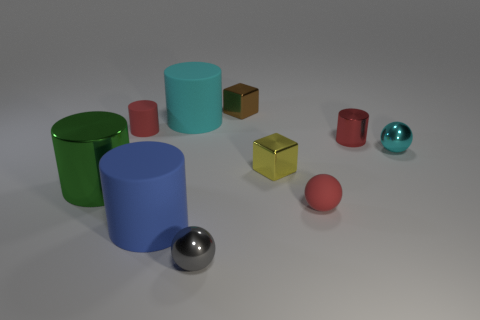What material is the red object that is behind the tiny yellow cube and to the right of the tiny gray shiny sphere?
Ensure brevity in your answer.  Metal. What number of tiny red rubber objects have the same shape as the small brown thing?
Give a very brief answer. 0. There is a sphere that is on the right side of the small red cylinder right of the blue matte cylinder; what is its size?
Give a very brief answer. Small. There is a small object that is right of the tiny red metallic cylinder; is it the same color as the big matte thing behind the blue thing?
Make the answer very short. Yes. There is a small shiny ball in front of the red thing in front of the large green metallic object; what number of small objects are behind it?
Make the answer very short. 6. What number of objects are in front of the large green shiny thing and right of the gray shiny sphere?
Your response must be concise. 1. Are there more red cylinders behind the big blue cylinder than tiny cyan spheres?
Provide a short and direct response. Yes. What number of green metallic things are the same size as the blue matte cylinder?
Your response must be concise. 1. How many large things are green shiny cylinders or purple rubber spheres?
Your answer should be very brief. 1. What number of tiny green matte objects are there?
Give a very brief answer. 0. 